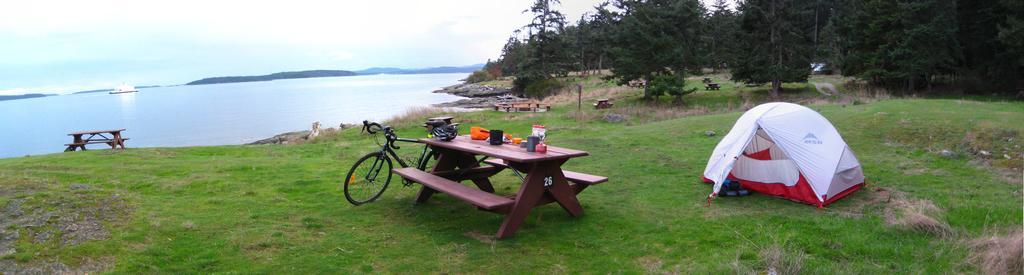Describe this image in one or two sentences. In this image on the right side of the top there are trees and on the bottom of the right corner there is grass and one tent is there and in the middle there is one table and two chairs are there and on the table there are some containers and on the left side there is grass and on the top of the left side there is sky and in the middle there is water and beside the table there is one cycle. 